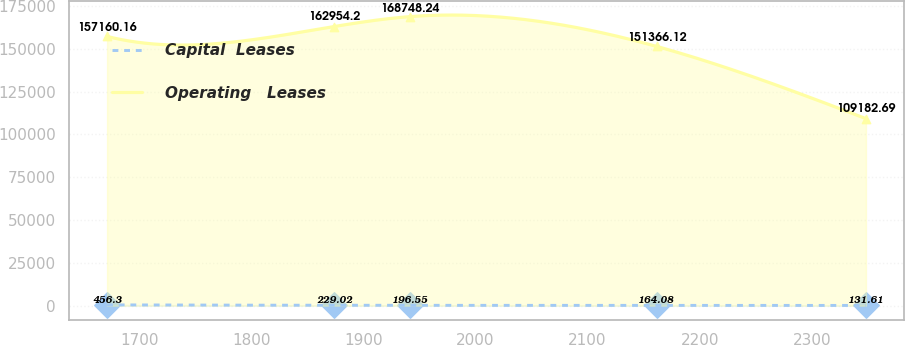Convert chart. <chart><loc_0><loc_0><loc_500><loc_500><line_chart><ecel><fcel>Capital  Leases<fcel>Operating   Leases<nl><fcel>1671.27<fcel>456.3<fcel>157160<nl><fcel>1873.86<fcel>229.02<fcel>162954<nl><fcel>1941.57<fcel>196.55<fcel>168748<nl><fcel>2161.5<fcel>164.08<fcel>151366<nl><fcel>2348.35<fcel>131.61<fcel>109183<nl></chart> 